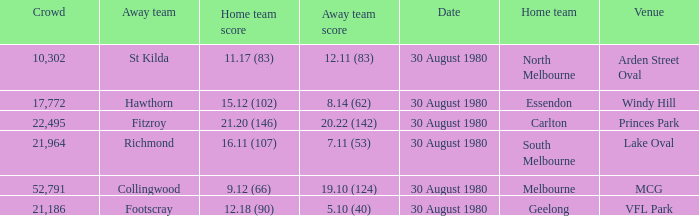What was the score for south melbourne at home? 16.11 (107). 